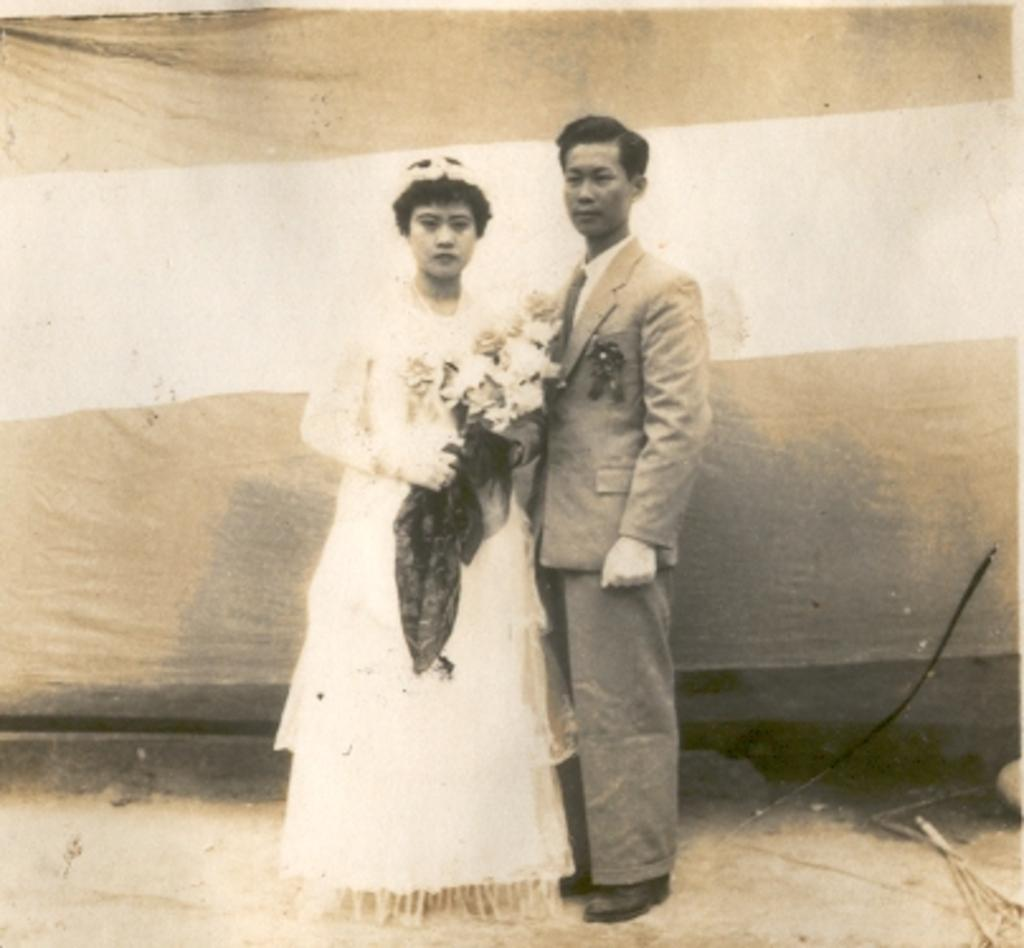How many people are in the image? There are two people in the image, a man and a woman. What are the man and woman doing in the image? Both the man and woman are standing in the center of the image. Can you describe the woman in the image? The woman is holding a bouquet. What can be seen in the background of the image? There appears to be a curtain in the background of the image. What type of glue is being used by the spy in the image? There is no spy or glue present in the image. Can you tell me how many rats are visible in the image? There are no rats visible in the image. 